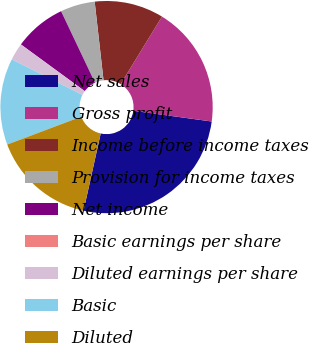<chart> <loc_0><loc_0><loc_500><loc_500><pie_chart><fcel>Net sales<fcel>Gross profit<fcel>Income before income taxes<fcel>Provision for income taxes<fcel>Net income<fcel>Basic earnings per share<fcel>Diluted earnings per share<fcel>Basic<fcel>Diluted<nl><fcel>26.31%<fcel>18.42%<fcel>10.53%<fcel>5.26%<fcel>7.9%<fcel>0.0%<fcel>2.63%<fcel>13.16%<fcel>15.79%<nl></chart> 